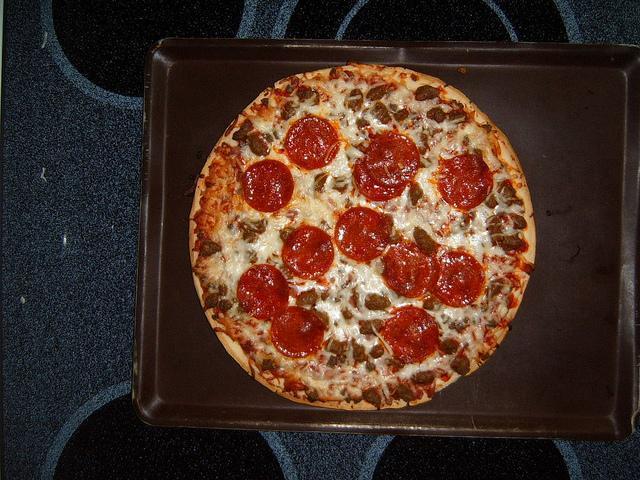Is this affirmation: "The oven is above the pizza." correct?
Answer yes or no. No. 